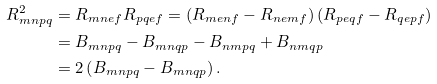<formula> <loc_0><loc_0><loc_500><loc_500>R _ { m n p q } ^ { 2 } & = R _ { m n e f } R _ { p q e f } = \left ( R _ { m e n f } - R _ { n e m f } \right ) \left ( R _ { p e q f } - R _ { q e p f } \right ) \\ & = B _ { m n p q } - B _ { m n q p } - B _ { n m p q } + B _ { n m q p } \\ & = 2 \left ( B _ { m n p q } - B _ { m n q p } \right ) .</formula> 